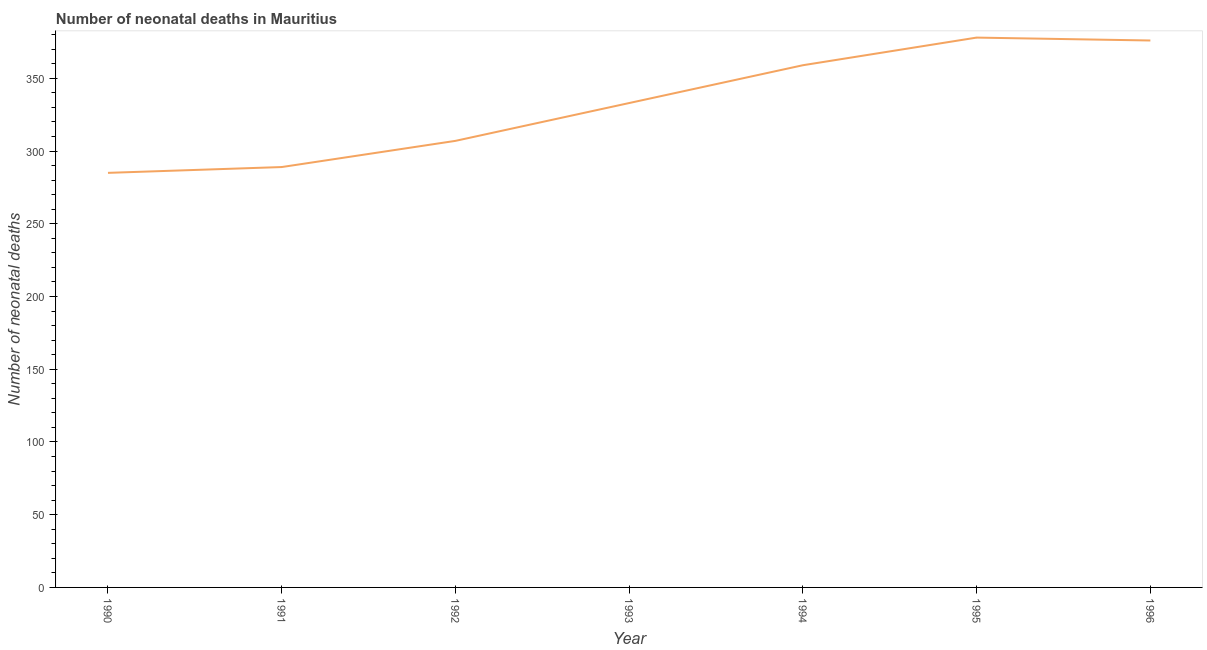What is the number of neonatal deaths in 1990?
Your answer should be compact. 285. Across all years, what is the maximum number of neonatal deaths?
Make the answer very short. 378. Across all years, what is the minimum number of neonatal deaths?
Give a very brief answer. 285. What is the sum of the number of neonatal deaths?
Offer a very short reply. 2327. What is the difference between the number of neonatal deaths in 1991 and 1995?
Ensure brevity in your answer.  -89. What is the average number of neonatal deaths per year?
Your response must be concise. 332.43. What is the median number of neonatal deaths?
Offer a terse response. 333. What is the ratio of the number of neonatal deaths in 1991 to that in 1992?
Offer a very short reply. 0.94. Is the number of neonatal deaths in 1991 less than that in 1995?
Ensure brevity in your answer.  Yes. Is the difference between the number of neonatal deaths in 1990 and 1995 greater than the difference between any two years?
Offer a very short reply. Yes. What is the difference between the highest and the lowest number of neonatal deaths?
Make the answer very short. 93. Does the number of neonatal deaths monotonically increase over the years?
Offer a very short reply. No. Does the graph contain any zero values?
Your answer should be very brief. No. What is the title of the graph?
Offer a terse response. Number of neonatal deaths in Mauritius. What is the label or title of the Y-axis?
Provide a short and direct response. Number of neonatal deaths. What is the Number of neonatal deaths of 1990?
Provide a succinct answer. 285. What is the Number of neonatal deaths of 1991?
Ensure brevity in your answer.  289. What is the Number of neonatal deaths in 1992?
Give a very brief answer. 307. What is the Number of neonatal deaths in 1993?
Make the answer very short. 333. What is the Number of neonatal deaths of 1994?
Give a very brief answer. 359. What is the Number of neonatal deaths of 1995?
Offer a terse response. 378. What is the Number of neonatal deaths in 1996?
Keep it short and to the point. 376. What is the difference between the Number of neonatal deaths in 1990 and 1993?
Provide a succinct answer. -48. What is the difference between the Number of neonatal deaths in 1990 and 1994?
Ensure brevity in your answer.  -74. What is the difference between the Number of neonatal deaths in 1990 and 1995?
Your response must be concise. -93. What is the difference between the Number of neonatal deaths in 1990 and 1996?
Give a very brief answer. -91. What is the difference between the Number of neonatal deaths in 1991 and 1993?
Your response must be concise. -44. What is the difference between the Number of neonatal deaths in 1991 and 1994?
Ensure brevity in your answer.  -70. What is the difference between the Number of neonatal deaths in 1991 and 1995?
Your answer should be very brief. -89. What is the difference between the Number of neonatal deaths in 1991 and 1996?
Provide a short and direct response. -87. What is the difference between the Number of neonatal deaths in 1992 and 1994?
Your answer should be very brief. -52. What is the difference between the Number of neonatal deaths in 1992 and 1995?
Offer a very short reply. -71. What is the difference between the Number of neonatal deaths in 1992 and 1996?
Offer a terse response. -69. What is the difference between the Number of neonatal deaths in 1993 and 1995?
Make the answer very short. -45. What is the difference between the Number of neonatal deaths in 1993 and 1996?
Offer a very short reply. -43. What is the difference between the Number of neonatal deaths in 1994 and 1996?
Make the answer very short. -17. What is the ratio of the Number of neonatal deaths in 1990 to that in 1992?
Offer a very short reply. 0.93. What is the ratio of the Number of neonatal deaths in 1990 to that in 1993?
Ensure brevity in your answer.  0.86. What is the ratio of the Number of neonatal deaths in 1990 to that in 1994?
Offer a terse response. 0.79. What is the ratio of the Number of neonatal deaths in 1990 to that in 1995?
Your answer should be compact. 0.75. What is the ratio of the Number of neonatal deaths in 1990 to that in 1996?
Keep it short and to the point. 0.76. What is the ratio of the Number of neonatal deaths in 1991 to that in 1992?
Keep it short and to the point. 0.94. What is the ratio of the Number of neonatal deaths in 1991 to that in 1993?
Your response must be concise. 0.87. What is the ratio of the Number of neonatal deaths in 1991 to that in 1994?
Ensure brevity in your answer.  0.81. What is the ratio of the Number of neonatal deaths in 1991 to that in 1995?
Your response must be concise. 0.77. What is the ratio of the Number of neonatal deaths in 1991 to that in 1996?
Offer a very short reply. 0.77. What is the ratio of the Number of neonatal deaths in 1992 to that in 1993?
Ensure brevity in your answer.  0.92. What is the ratio of the Number of neonatal deaths in 1992 to that in 1994?
Offer a terse response. 0.85. What is the ratio of the Number of neonatal deaths in 1992 to that in 1995?
Make the answer very short. 0.81. What is the ratio of the Number of neonatal deaths in 1992 to that in 1996?
Provide a short and direct response. 0.82. What is the ratio of the Number of neonatal deaths in 1993 to that in 1994?
Offer a terse response. 0.93. What is the ratio of the Number of neonatal deaths in 1993 to that in 1995?
Your answer should be very brief. 0.88. What is the ratio of the Number of neonatal deaths in 1993 to that in 1996?
Provide a succinct answer. 0.89. What is the ratio of the Number of neonatal deaths in 1994 to that in 1995?
Provide a short and direct response. 0.95. What is the ratio of the Number of neonatal deaths in 1994 to that in 1996?
Give a very brief answer. 0.95. What is the ratio of the Number of neonatal deaths in 1995 to that in 1996?
Make the answer very short. 1. 